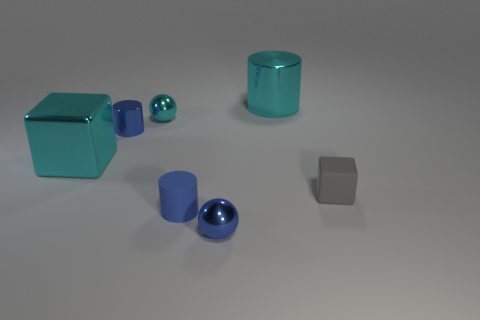Are there any red rubber objects that have the same shape as the small gray object?
Offer a terse response. No. The gray matte thing that is the same size as the cyan metal ball is what shape?
Provide a short and direct response. Cube. Are there any tiny blue objects to the left of the large thing that is behind the blue shiny thing that is behind the tiny block?
Keep it short and to the point. Yes. Is there a green thing of the same size as the blue ball?
Your answer should be very brief. No. There is a blue cylinder that is in front of the cyan cube; what is its size?
Your answer should be very brief. Small. What color is the ball in front of the blue metallic object that is behind the big thing that is to the left of the large cylinder?
Provide a succinct answer. Blue. What color is the cylinder that is in front of the big cyan shiny object that is to the left of the small blue matte thing?
Offer a terse response. Blue. Is the number of cyan blocks in front of the cyan ball greater than the number of blue cylinders that are behind the blue shiny cylinder?
Provide a succinct answer. Yes. Are the cyan thing that is on the right side of the small matte cylinder and the large cyan object that is in front of the small cyan metallic object made of the same material?
Provide a succinct answer. Yes. Are there any cyan cylinders left of the tiny cyan object?
Make the answer very short. No. 